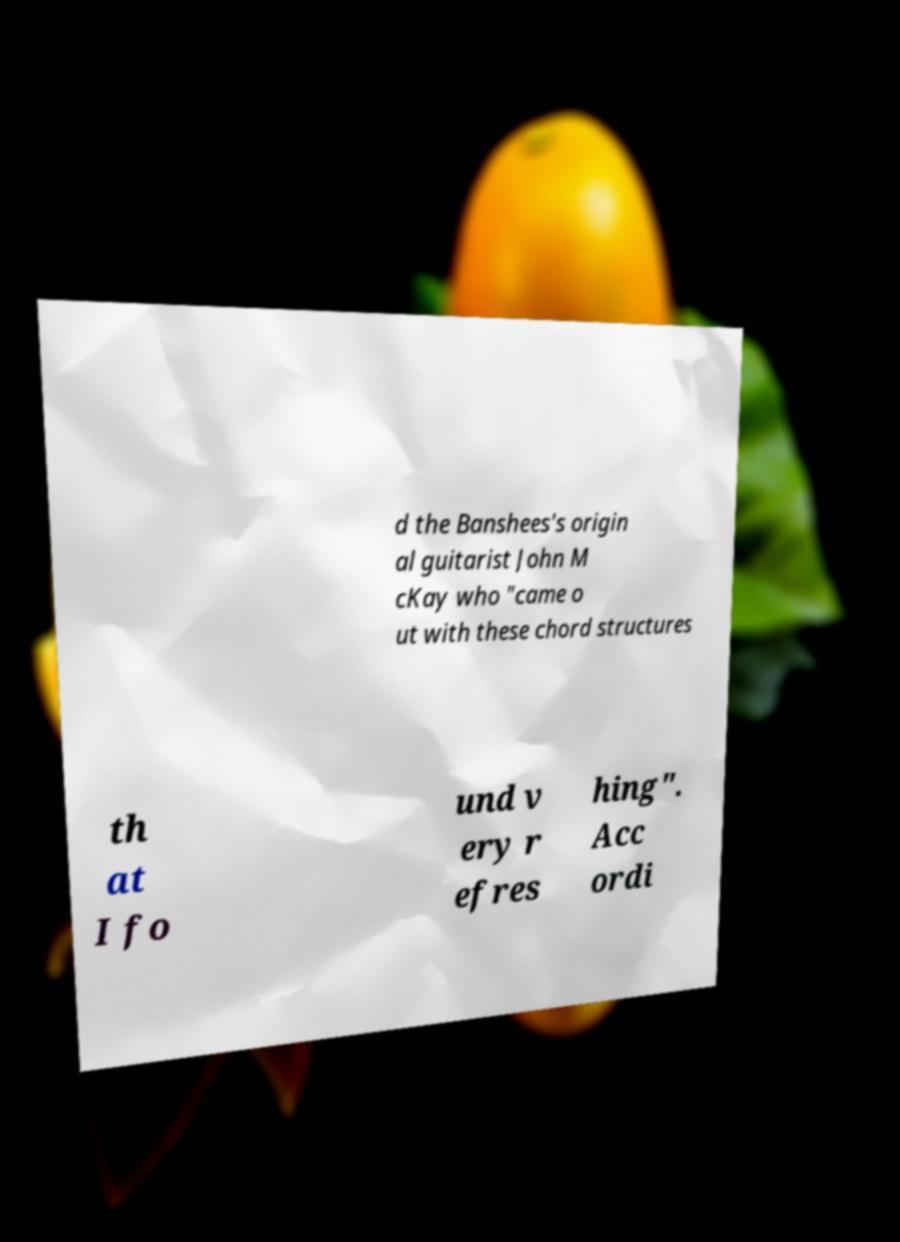Please read and relay the text visible in this image. What does it say? d the Banshees's origin al guitarist John M cKay who "came o ut with these chord structures th at I fo und v ery r efres hing". Acc ordi 